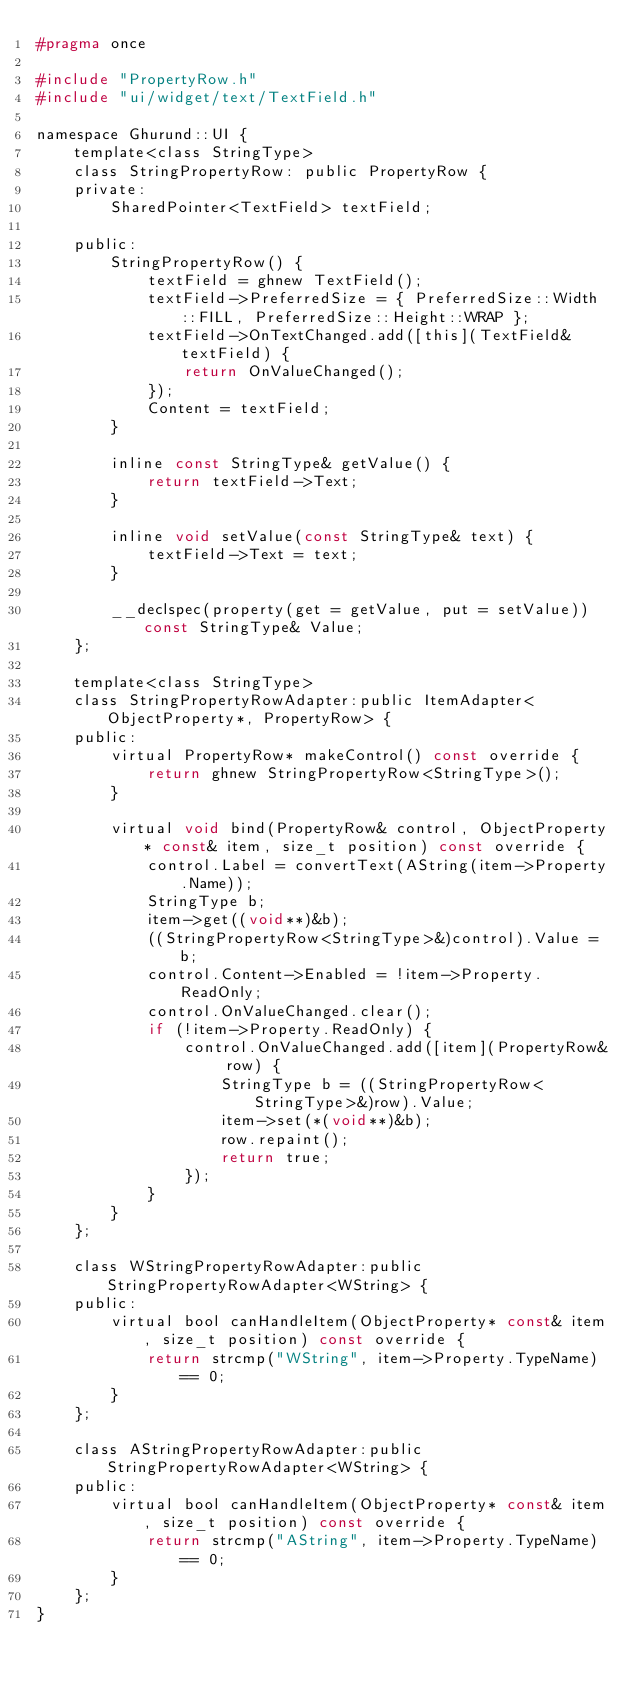Convert code to text. <code><loc_0><loc_0><loc_500><loc_500><_C_>#pragma once

#include "PropertyRow.h"
#include "ui/widget/text/TextField.h"

namespace Ghurund::UI {
    template<class StringType>
    class StringPropertyRow: public PropertyRow {
    private:
        SharedPointer<TextField> textField;

    public:
        StringPropertyRow() {
            textField = ghnew TextField();
            textField->PreferredSize = { PreferredSize::Width::FILL, PreferredSize::Height::WRAP };
            textField->OnTextChanged.add([this](TextField& textField) {
                return OnValueChanged();
            });
            Content = textField;
        }

        inline const StringType& getValue() {
            return textField->Text;
        }

        inline void setValue(const StringType& text) {
            textField->Text = text;
        }

        __declspec(property(get = getValue, put = setValue)) const StringType& Value;
    };

    template<class StringType>
    class StringPropertyRowAdapter:public ItemAdapter<ObjectProperty*, PropertyRow> {
    public:
        virtual PropertyRow* makeControl() const override {
            return ghnew StringPropertyRow<StringType>();
        }

        virtual void bind(PropertyRow& control, ObjectProperty* const& item, size_t position) const override {
            control.Label = convertText(AString(item->Property.Name));
            StringType b;
            item->get((void**)&b);
            ((StringPropertyRow<StringType>&)control).Value = b;
            control.Content->Enabled = !item->Property.ReadOnly;
            control.OnValueChanged.clear();
            if (!item->Property.ReadOnly) {
                control.OnValueChanged.add([item](PropertyRow& row) {
                    StringType b = ((StringPropertyRow<StringType>&)row).Value;
                    item->set(*(void**)&b);
                    row.repaint();
                    return true;
                });
            }
        }
    };

    class WStringPropertyRowAdapter:public StringPropertyRowAdapter<WString> {
    public:
        virtual bool canHandleItem(ObjectProperty* const& item, size_t position) const override {
            return strcmp("WString", item->Property.TypeName) == 0;
        }
    };

    class AStringPropertyRowAdapter:public StringPropertyRowAdapter<WString> {
    public:
        virtual bool canHandleItem(ObjectProperty* const& item, size_t position) const override {
            return strcmp("AString", item->Property.TypeName) == 0;
        }
    };
}</code> 